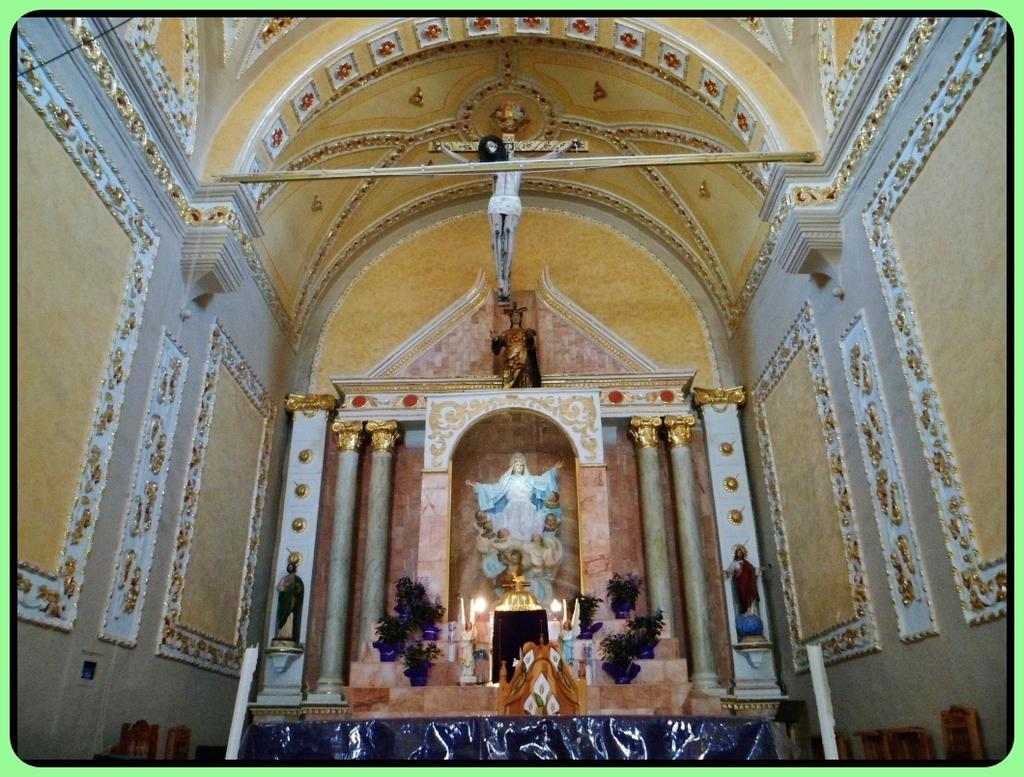What type of building is in the image? There is a church in the image. What can be found inside the church? There are Jesus statues in the church. What objects are present in the image that might be used for lighting or religious purposes? There are candles in the image. What type of decorative items can be seen in the image? There are flower pots in the image. What type of print can be seen on the ship's sails in the image? There is no ship present in the image, so there are no sails or prints to observe. 